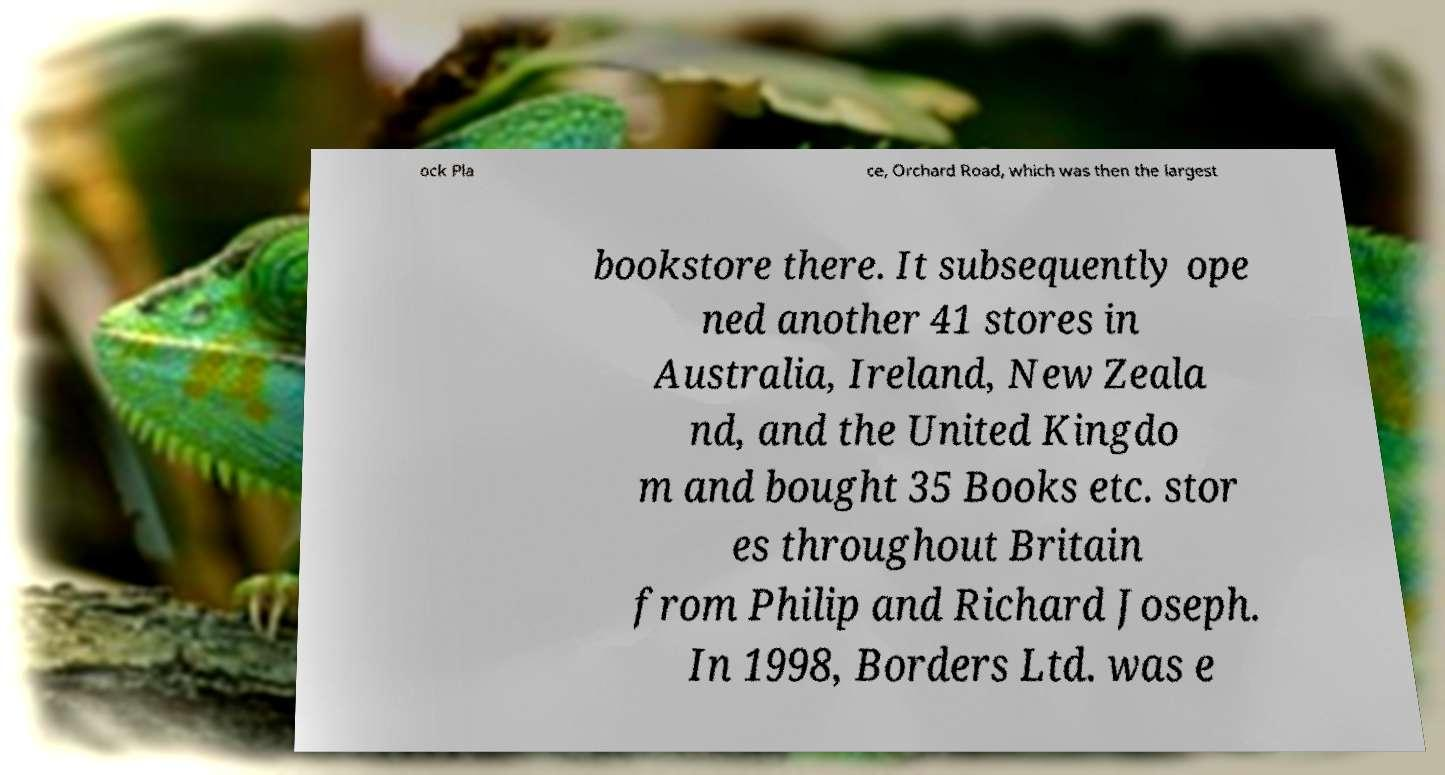Please identify and transcribe the text found in this image. ock Pla ce, Orchard Road, which was then the largest bookstore there. It subsequently ope ned another 41 stores in Australia, Ireland, New Zeala nd, and the United Kingdo m and bought 35 Books etc. stor es throughout Britain from Philip and Richard Joseph. In 1998, Borders Ltd. was e 